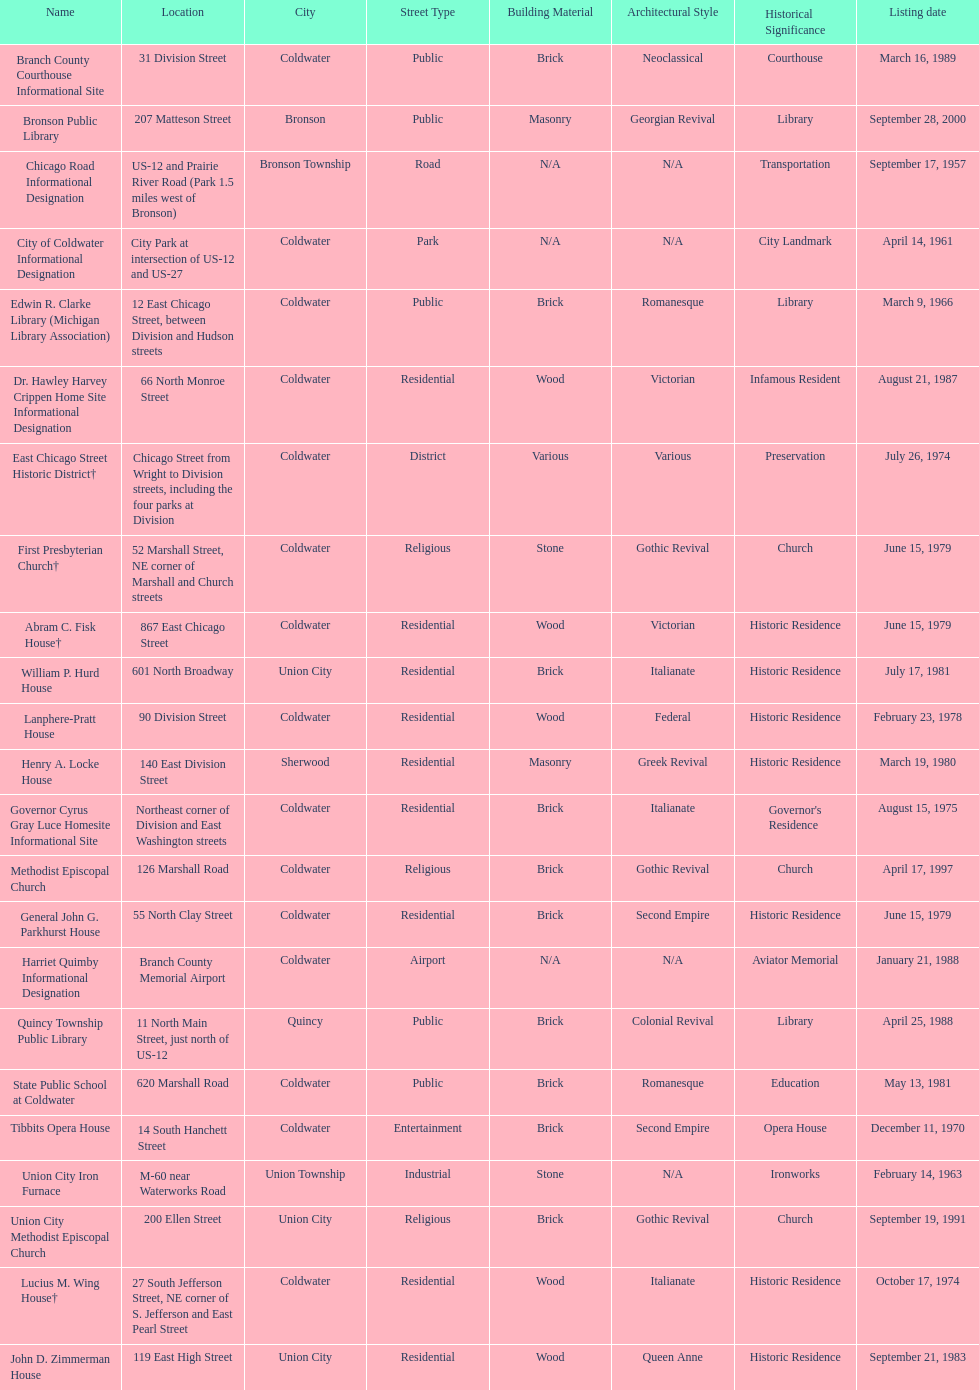Which site was listed earlier, the state public school or the edwin r. clarke library? Edwin R. Clarke Library. 